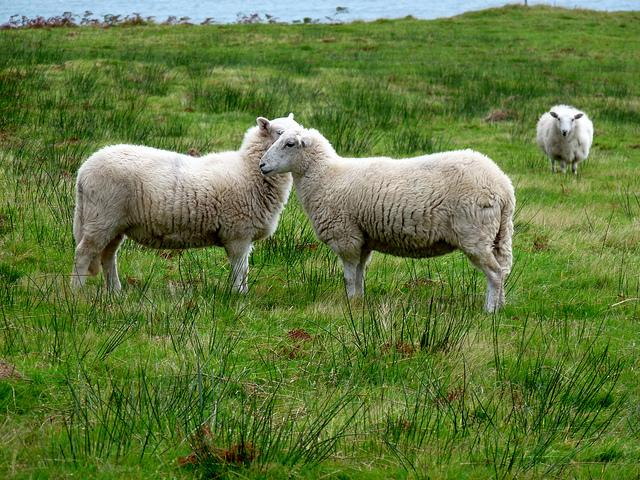How many sheep are standing around in the cape field? three 